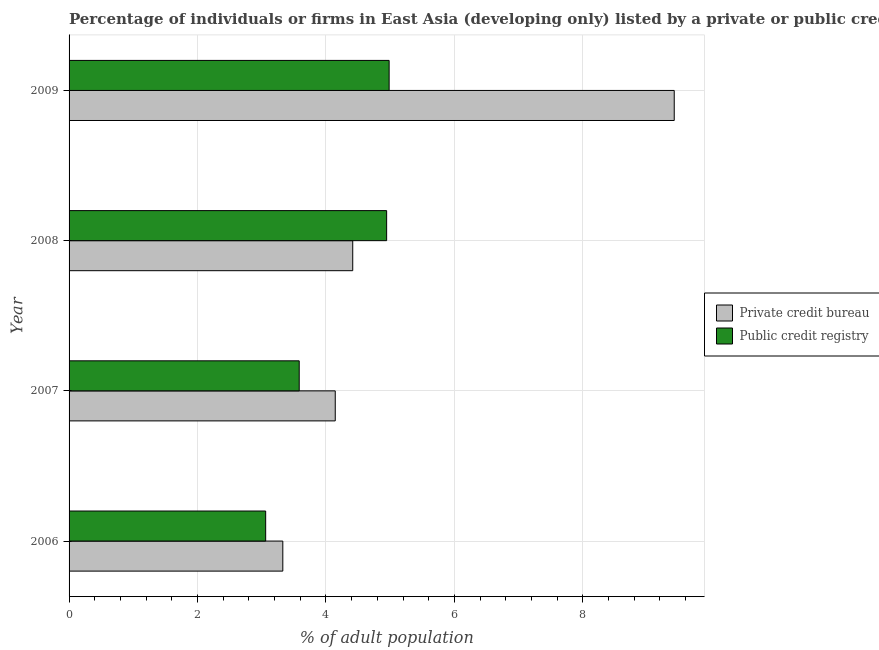How many groups of bars are there?
Your answer should be compact. 4. Are the number of bars on each tick of the Y-axis equal?
Give a very brief answer. Yes. How many bars are there on the 1st tick from the top?
Offer a very short reply. 2. How many bars are there on the 4th tick from the bottom?
Keep it short and to the point. 2. In how many cases, is the number of bars for a given year not equal to the number of legend labels?
Offer a very short reply. 0. What is the percentage of firms listed by private credit bureau in 2006?
Provide a succinct answer. 3.33. Across all years, what is the maximum percentage of firms listed by public credit bureau?
Offer a terse response. 4.98. Across all years, what is the minimum percentage of firms listed by private credit bureau?
Your answer should be compact. 3.33. In which year was the percentage of firms listed by public credit bureau minimum?
Keep it short and to the point. 2006. What is the total percentage of firms listed by private credit bureau in the graph?
Your answer should be very brief. 21.31. What is the difference between the percentage of firms listed by private credit bureau in 2007 and that in 2008?
Your response must be concise. -0.27. What is the difference between the percentage of firms listed by public credit bureau in 2009 and the percentage of firms listed by private credit bureau in 2007?
Ensure brevity in your answer.  0.84. What is the average percentage of firms listed by private credit bureau per year?
Offer a terse response. 5.33. In the year 2007, what is the difference between the percentage of firms listed by private credit bureau and percentage of firms listed by public credit bureau?
Provide a succinct answer. 0.56. What is the ratio of the percentage of firms listed by private credit bureau in 2006 to that in 2008?
Your response must be concise. 0.75. Is the difference between the percentage of firms listed by public credit bureau in 2006 and 2008 greater than the difference between the percentage of firms listed by private credit bureau in 2006 and 2008?
Your answer should be very brief. No. What is the difference between the highest and the second highest percentage of firms listed by private credit bureau?
Offer a terse response. 5.01. What is the difference between the highest and the lowest percentage of firms listed by public credit bureau?
Your answer should be very brief. 1.92. In how many years, is the percentage of firms listed by private credit bureau greater than the average percentage of firms listed by private credit bureau taken over all years?
Your answer should be very brief. 1. Is the sum of the percentage of firms listed by public credit bureau in 2006 and 2009 greater than the maximum percentage of firms listed by private credit bureau across all years?
Ensure brevity in your answer.  No. What does the 2nd bar from the top in 2008 represents?
Offer a terse response. Private credit bureau. What does the 1st bar from the bottom in 2006 represents?
Provide a short and direct response. Private credit bureau. How many bars are there?
Give a very brief answer. 8. Are all the bars in the graph horizontal?
Your answer should be very brief. Yes. How many years are there in the graph?
Provide a succinct answer. 4. Are the values on the major ticks of X-axis written in scientific E-notation?
Keep it short and to the point. No. Does the graph contain any zero values?
Your answer should be very brief. No. Does the graph contain grids?
Provide a short and direct response. Yes. How are the legend labels stacked?
Keep it short and to the point. Vertical. What is the title of the graph?
Offer a terse response. Percentage of individuals or firms in East Asia (developing only) listed by a private or public credit bureau. Does "Death rate" appear as one of the legend labels in the graph?
Provide a short and direct response. No. What is the label or title of the X-axis?
Ensure brevity in your answer.  % of adult population. What is the label or title of the Y-axis?
Keep it short and to the point. Year. What is the % of adult population of Private credit bureau in 2006?
Offer a very short reply. 3.33. What is the % of adult population in Public credit registry in 2006?
Your answer should be compact. 3.06. What is the % of adult population of Private credit bureau in 2007?
Your response must be concise. 4.14. What is the % of adult population of Public credit registry in 2007?
Give a very brief answer. 3.58. What is the % of adult population of Private credit bureau in 2008?
Your response must be concise. 4.42. What is the % of adult population in Public credit registry in 2008?
Offer a terse response. 4.94. What is the % of adult population in Private credit bureau in 2009?
Give a very brief answer. 9.42. What is the % of adult population in Public credit registry in 2009?
Your answer should be compact. 4.98. Across all years, what is the maximum % of adult population in Private credit bureau?
Provide a succinct answer. 9.42. Across all years, what is the maximum % of adult population of Public credit registry?
Offer a very short reply. 4.98. Across all years, what is the minimum % of adult population in Private credit bureau?
Provide a short and direct response. 3.33. Across all years, what is the minimum % of adult population in Public credit registry?
Ensure brevity in your answer.  3.06. What is the total % of adult population in Private credit bureau in the graph?
Ensure brevity in your answer.  21.31. What is the total % of adult population in Public credit registry in the graph?
Give a very brief answer. 16.57. What is the difference between the % of adult population of Private credit bureau in 2006 and that in 2007?
Your answer should be very brief. -0.82. What is the difference between the % of adult population of Public credit registry in 2006 and that in 2007?
Offer a very short reply. -0.52. What is the difference between the % of adult population in Private credit bureau in 2006 and that in 2008?
Keep it short and to the point. -1.09. What is the difference between the % of adult population of Public credit registry in 2006 and that in 2008?
Offer a terse response. -1.88. What is the difference between the % of adult population in Private credit bureau in 2006 and that in 2009?
Your response must be concise. -6.09. What is the difference between the % of adult population in Public credit registry in 2006 and that in 2009?
Your response must be concise. -1.92. What is the difference between the % of adult population of Private credit bureau in 2007 and that in 2008?
Keep it short and to the point. -0.27. What is the difference between the % of adult population in Public credit registry in 2007 and that in 2008?
Your answer should be compact. -1.36. What is the difference between the % of adult population of Private credit bureau in 2007 and that in 2009?
Provide a short and direct response. -5.28. What is the difference between the % of adult population in Private credit bureau in 2008 and that in 2009?
Give a very brief answer. -5.01. What is the difference between the % of adult population of Public credit registry in 2008 and that in 2009?
Ensure brevity in your answer.  -0.04. What is the difference between the % of adult population in Private credit bureau in 2006 and the % of adult population in Public credit registry in 2007?
Make the answer very short. -0.26. What is the difference between the % of adult population in Private credit bureau in 2006 and the % of adult population in Public credit registry in 2008?
Ensure brevity in your answer.  -1.62. What is the difference between the % of adult population in Private credit bureau in 2006 and the % of adult population in Public credit registry in 2009?
Provide a short and direct response. -1.66. What is the difference between the % of adult population of Private credit bureau in 2007 and the % of adult population of Public credit registry in 2008?
Offer a very short reply. -0.8. What is the difference between the % of adult population of Private credit bureau in 2007 and the % of adult population of Public credit registry in 2009?
Ensure brevity in your answer.  -0.84. What is the difference between the % of adult population in Private credit bureau in 2008 and the % of adult population in Public credit registry in 2009?
Your answer should be compact. -0.57. What is the average % of adult population in Private credit bureau per year?
Your response must be concise. 5.33. What is the average % of adult population of Public credit registry per year?
Provide a short and direct response. 4.14. In the year 2006, what is the difference between the % of adult population of Private credit bureau and % of adult population of Public credit registry?
Ensure brevity in your answer.  0.27. In the year 2007, what is the difference between the % of adult population of Private credit bureau and % of adult population of Public credit registry?
Your answer should be very brief. 0.56. In the year 2008, what is the difference between the % of adult population of Private credit bureau and % of adult population of Public credit registry?
Your response must be concise. -0.53. In the year 2009, what is the difference between the % of adult population of Private credit bureau and % of adult population of Public credit registry?
Ensure brevity in your answer.  4.44. What is the ratio of the % of adult population in Private credit bureau in 2006 to that in 2007?
Offer a terse response. 0.8. What is the ratio of the % of adult population of Public credit registry in 2006 to that in 2007?
Provide a short and direct response. 0.85. What is the ratio of the % of adult population in Private credit bureau in 2006 to that in 2008?
Your answer should be compact. 0.75. What is the ratio of the % of adult population of Public credit registry in 2006 to that in 2008?
Your answer should be very brief. 0.62. What is the ratio of the % of adult population in Private credit bureau in 2006 to that in 2009?
Provide a short and direct response. 0.35. What is the ratio of the % of adult population of Public credit registry in 2006 to that in 2009?
Provide a short and direct response. 0.61. What is the ratio of the % of adult population in Private credit bureau in 2007 to that in 2008?
Your response must be concise. 0.94. What is the ratio of the % of adult population of Public credit registry in 2007 to that in 2008?
Offer a very short reply. 0.72. What is the ratio of the % of adult population in Private credit bureau in 2007 to that in 2009?
Make the answer very short. 0.44. What is the ratio of the % of adult population in Public credit registry in 2007 to that in 2009?
Make the answer very short. 0.72. What is the ratio of the % of adult population of Private credit bureau in 2008 to that in 2009?
Offer a very short reply. 0.47. What is the ratio of the % of adult population of Public credit registry in 2008 to that in 2009?
Your answer should be very brief. 0.99. What is the difference between the highest and the second highest % of adult population of Private credit bureau?
Provide a succinct answer. 5.01. What is the difference between the highest and the second highest % of adult population of Public credit registry?
Your answer should be compact. 0.04. What is the difference between the highest and the lowest % of adult population of Private credit bureau?
Ensure brevity in your answer.  6.09. What is the difference between the highest and the lowest % of adult population in Public credit registry?
Your answer should be compact. 1.92. 